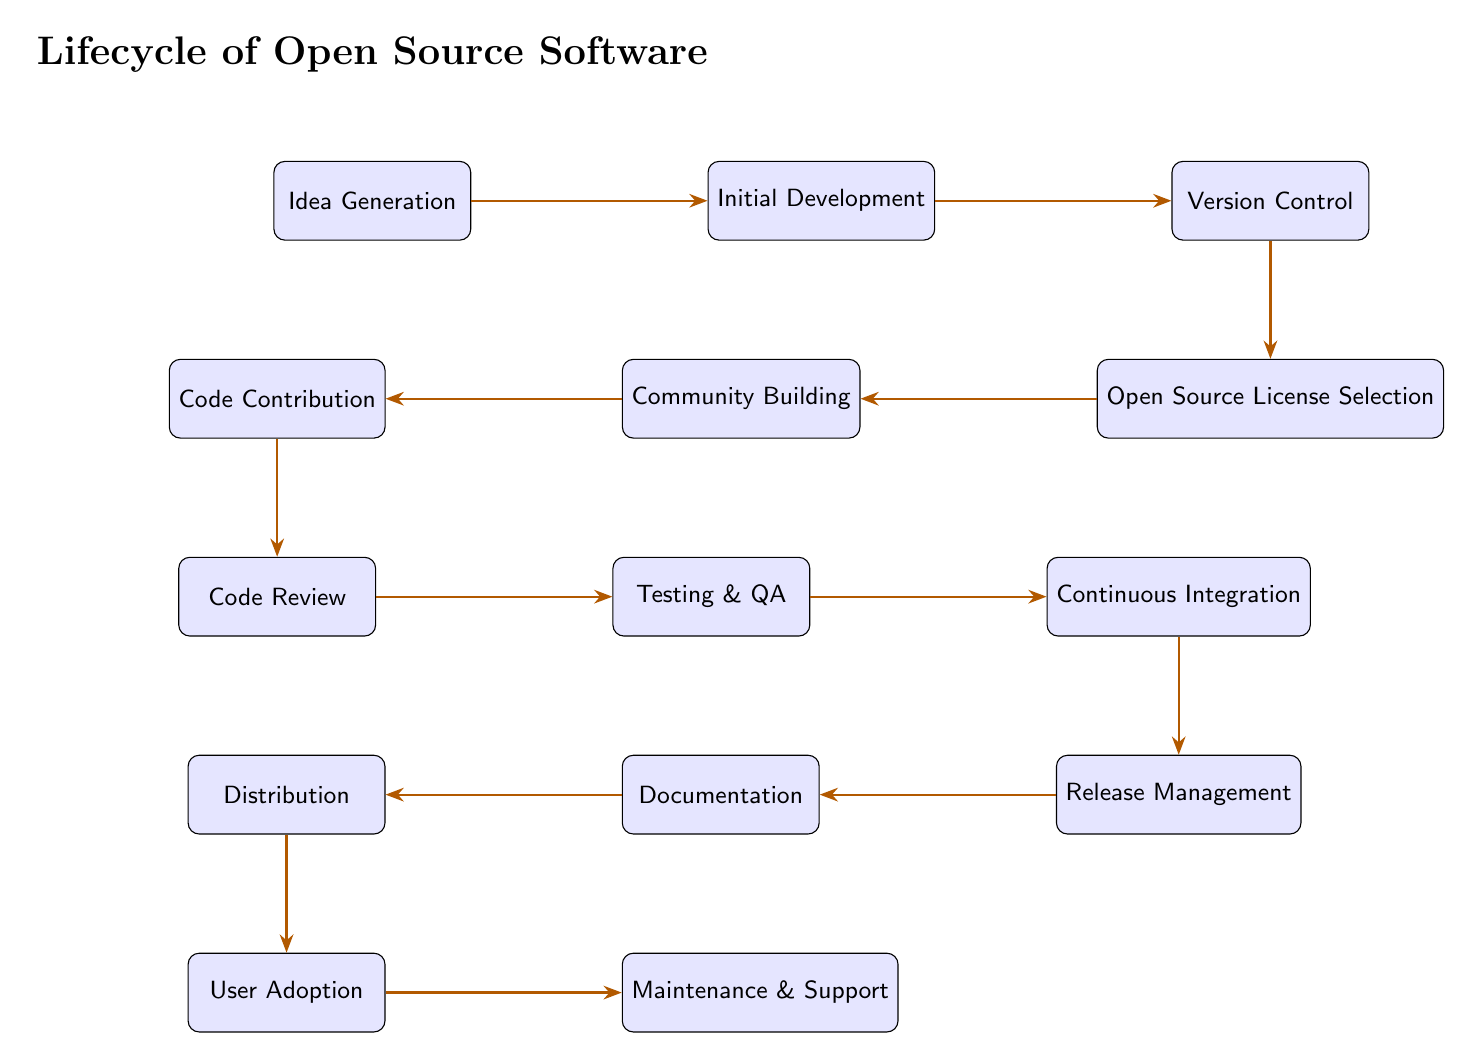What is the first stage in the OSS lifecycle? The diagram shows that the first node in the lifecycle of Open Source Software is "Idea Generation." This is the initial step where new software ideas are conceived.
Answer: Idea Generation How many nodes are present in the diagram? By visually counting each labeled node in the diagram, there are a total of 12 distinct nodes that represent various stages in the OSS lifecycle.
Answer: 12 What follows "Community Building" in the OSS lifecycle? The flow of the diagram indicates that "Community Building" is directly followed by "Code Contribution," which is the next step as illustrated in the progression.
Answer: Code Contribution Which node is directly below "Documentation"? Observing the layout, "Documentation" is positioned right above "Distribution," which is the node located directly below it according to the arrangement in the diagram.
Answer: Distribution What is the last stage in the OSS lifecycle? The diagram clearly shows that "Maintenance & Support" is the final node in the lifecycle, indicating that this is where ongoing support and maintenance take place after all other stages have been completed.
Answer: Maintenance & Support What is the relationship between "Testing & QA" and "Continuous Integration"? "Testing & QA" is depicted directly before "Continuous Integration" in the flow, indicating that testing occurs prior to integrating various code contributions in the operational process.
Answer: Testing precedes Continuous Integration Which two nodes are connected to "Release Management"? The diagram illustrates that both "Continuous Integration" and "Documentation" connect to "Release Management," as it appears after testing and before distribution in the sequence.
Answer: Continuous Integration and Documentation What stage comes after "User Adoption"? After following the flow from "User Adoption" in the diagram, it can be seen that the subsequent stage is "Maintenance & Support" which follows closely in the lifecycle progression.
Answer: Maintenance & Support How many edges are in the flow of the OSS lifecycle? By counting the arrows connecting the nodes in the diagram, we find there are 11 edges that represent the direct connections or transitions between the stages in the OSS lifecycle.
Answer: 11 